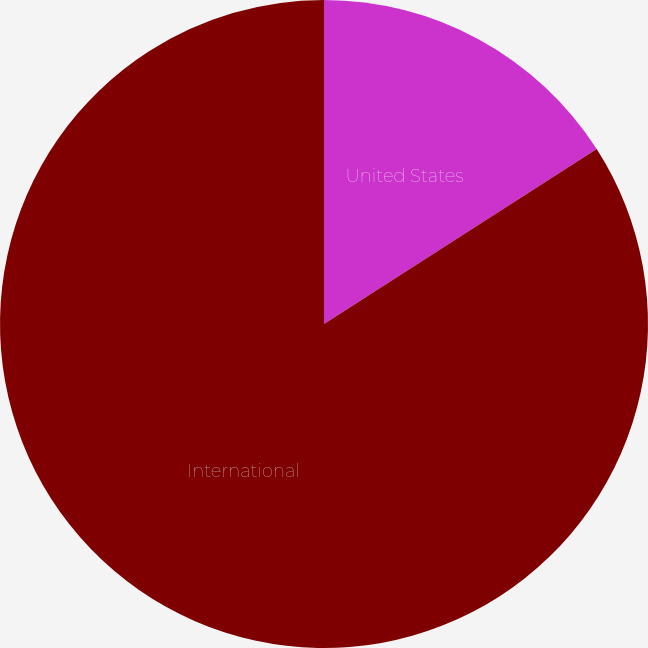Convert chart. <chart><loc_0><loc_0><loc_500><loc_500><pie_chart><fcel>United States<fcel>International<nl><fcel>15.92%<fcel>84.08%<nl></chart> 